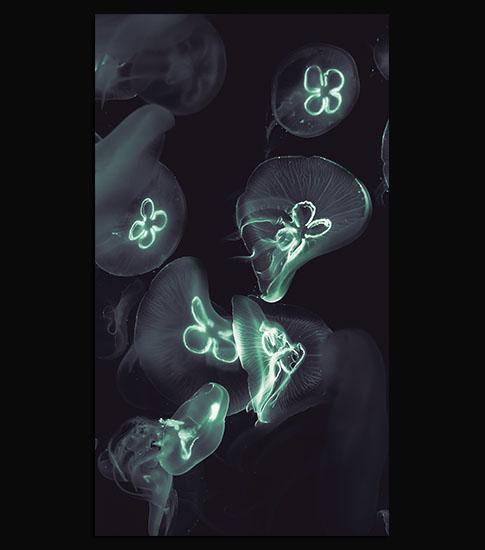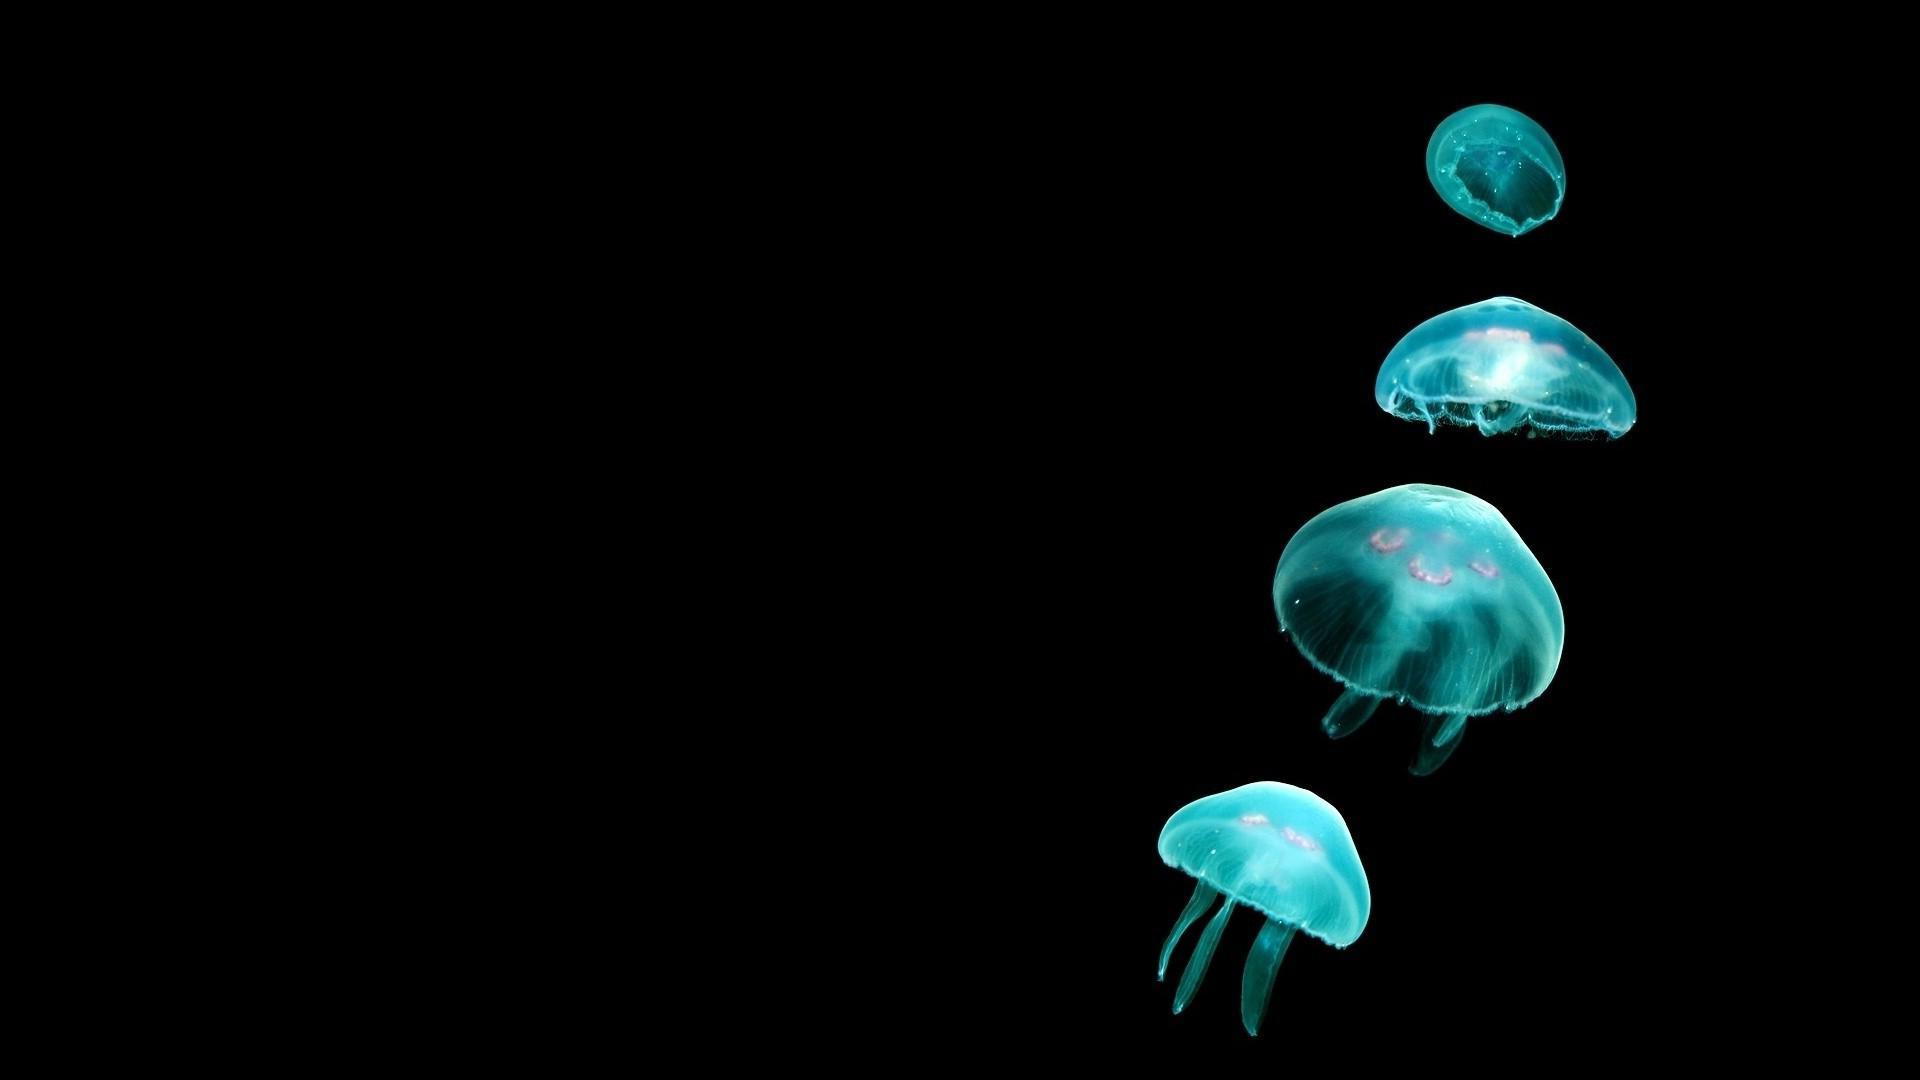The first image is the image on the left, the second image is the image on the right. For the images shown, is this caption "There are no more than five jellyfish in the image on the left" true? Answer yes or no. No. The first image is the image on the left, the second image is the image on the right. For the images shown, is this caption "Left image includes things that look like glowing blue jellyfish." true? Answer yes or no. No. 